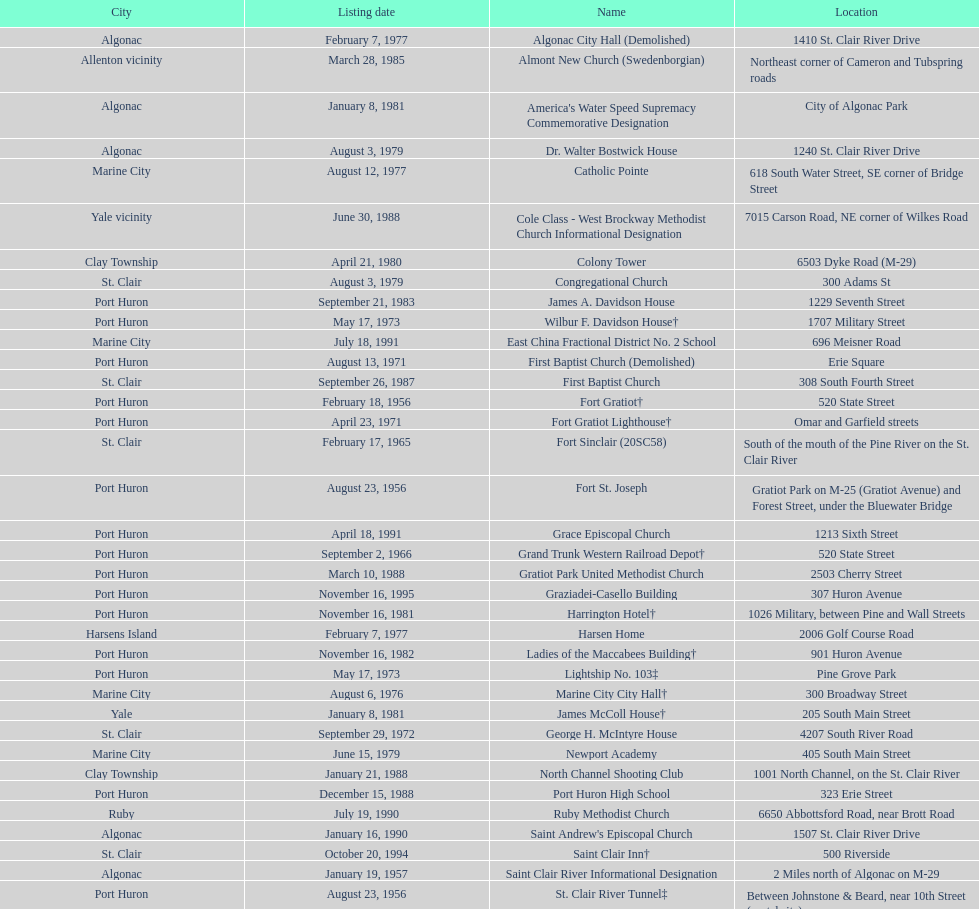What is the total number of locations in the city of algonac? 5. 